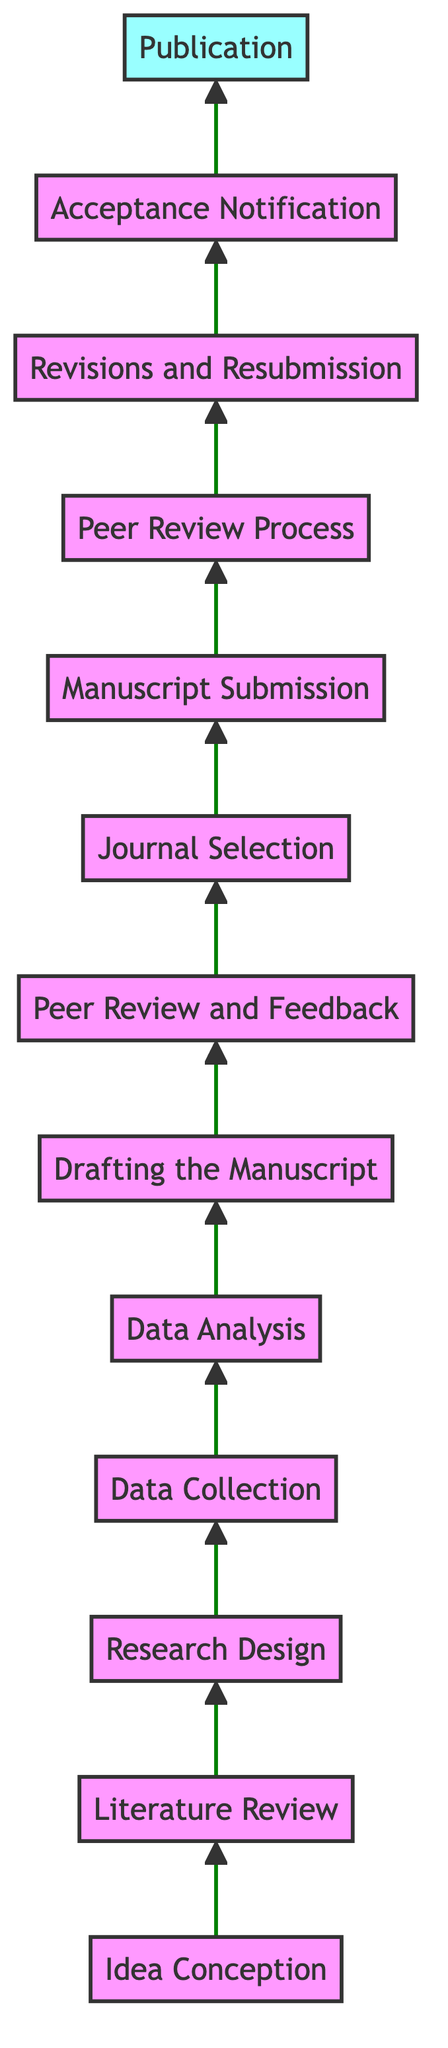What is the last step in the flow chart? The last step is represented by the final node in the diagram, which is "Publication."
Answer: Publication How many steps are there in total? Counting all the nodes in the flow chart, we have a total of thirteen distinct steps from "Idea Conception" to "Publication."
Answer: Thirteen Which step comes immediately after "Data Analysis"? The node immediately following "Data Analysis" in the diagram is "Drafting the Manuscript," indicated by a direct arrow pointing upwards.
Answer: Drafting the Manuscript What precedes the "Peer Review Process"? The step that comes just before "Peer Review Process" is "Manuscript Submission," as shown by the connecting arrow from it.
Answer: Manuscript Submission What is the relationship between "Revisions and Resubmission" and "Acceptance Notification"? "Revisions and Resubmission" directly leads into "Acceptance Notification," indicating that revisions must occur to receive acceptance.
Answer: Sequential Which two steps are connected by two nodes without any intervening steps? The two directly connected steps without any nodes in between are "Drafting the Manuscript" and "Peer Review and Feedback," which are linked consecutively.
Answer: Drafting the Manuscript, Peer Review and Feedback What is the purpose of "Literature Review" in the context of the diagram? "Literature Review" serves as a foundational step to anchor the research within existing knowledge, preceding the formulation of a research design.
Answer: Foundational step Which step involves external evaluation? The step "Peer Review Process" involves external evaluation where reviewers assess the manuscript's quality before acceptance.
Answer: Peer Review Process Is there a step that involves both collecting and analyzing data? No single step encompasses both data collection and analysis; they are clearly divided into "Data Collection" and "Data Analysis," showing sequential procedures.
Answer: No 